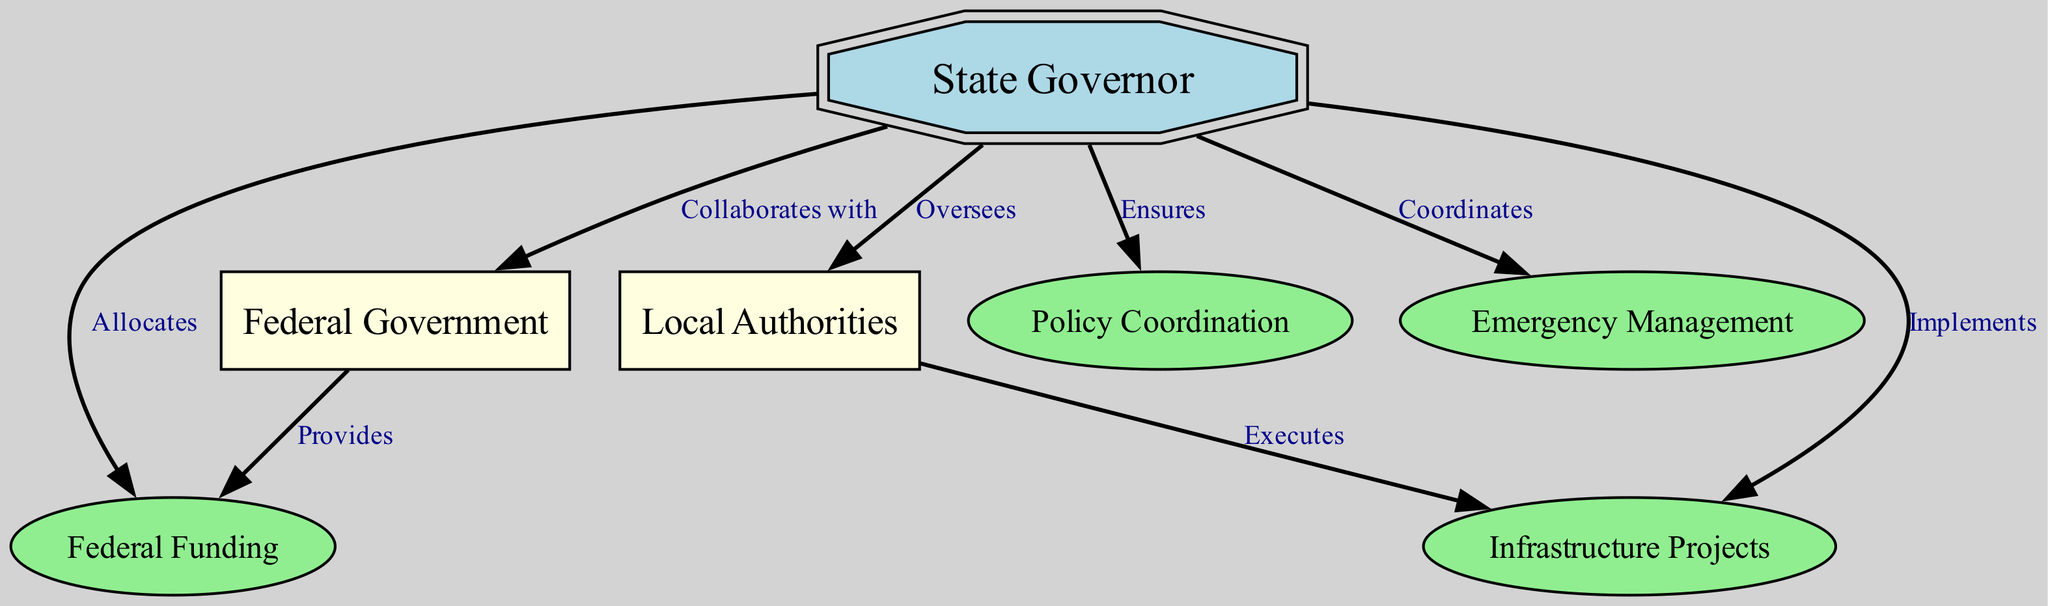What is the role of the State Governor in relation to the Federal Government? The diagram illustrates that the State Governor collaborates with the Federal Government. This is indicated by the edge connecting 'governor' to 'federal' labeled 'Collaborates with'.
Answer: Collaborates with How does the State Governor interact with Local Authorities? The Governor oversees Local Authorities, as shown by the edge from 'governor' to 'local' labeled 'Oversees'.
Answer: Oversees What does the Federal Government provide according to the diagram? The diagram indicates that the Federal Government provides funding, evident from the edge labeled 'Provides' connecting 'federal' to 'funding'.
Answer: Funding What function does the State Governor perform regarding infrastructure projects? The State Governor implements infrastructure projects, as depicted by the edge from 'governor' to 'infrastructure' labeled 'Implements'.
Answer: Implements How many edges are there in the diagram? To find the number of edges, we count the connections illustrated in the diagram. There are a total of 7 edges.
Answer: 7 What is the relationship between Local Authorities and infrastructure projects? The diagram shows that Local Authorities execute infrastructure projects, as indicated by the edge from 'local' to 'infrastructure' labeled 'Executes'.
Answer: Executes What aspect of emergency management does the State Governor coordinate? The State Governor coordinates emergency management, as represented by the edge from 'governor' to 'emergency' labeled 'Coordinates'.
Answer: Coordinates What key responsibility does the State Governor have regarding federal funding? According to the diagram, the State Governor allocates federal funding, which is shown by the edge from 'governor' to 'funding' labeled 'Allocates'.
Answer: Allocates In terms of policy, what does the State Governor ensure? The diagram defines that the State Governor ensures policy coordination, represented by the edge from 'governor' to 'policy' labeled 'Ensures'.
Answer: Ensures 